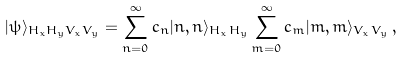Convert formula to latex. <formula><loc_0><loc_0><loc_500><loc_500>| \psi \rangle _ { H _ { x } H _ { y } V _ { x } V _ { y } } = \sum _ { n = 0 } ^ { \infty } c _ { n } | n , n \rangle _ { H _ { x } H _ { y } } \sum _ { m = 0 } ^ { \infty } c _ { m } | m , m \rangle _ { V _ { x } V _ { y } } \, ,</formula> 